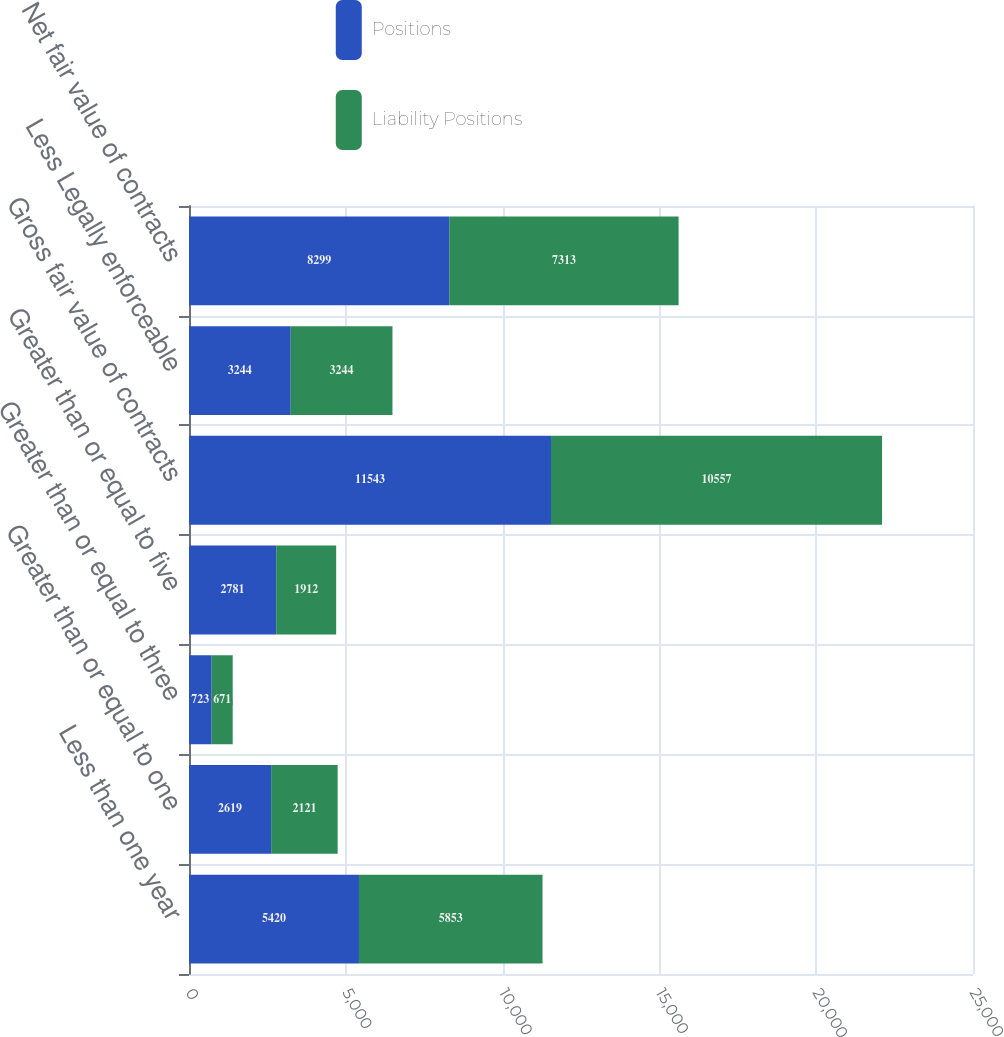Convert chart to OTSL. <chart><loc_0><loc_0><loc_500><loc_500><stacked_bar_chart><ecel><fcel>Less than one year<fcel>Greater than or equal to one<fcel>Greater than or equal to three<fcel>Greater than or equal to five<fcel>Gross fair value of contracts<fcel>Less Legally enforceable<fcel>Net fair value of contracts<nl><fcel>Positions<fcel>5420<fcel>2619<fcel>723<fcel>2781<fcel>11543<fcel>3244<fcel>8299<nl><fcel>Liability Positions<fcel>5853<fcel>2121<fcel>671<fcel>1912<fcel>10557<fcel>3244<fcel>7313<nl></chart> 